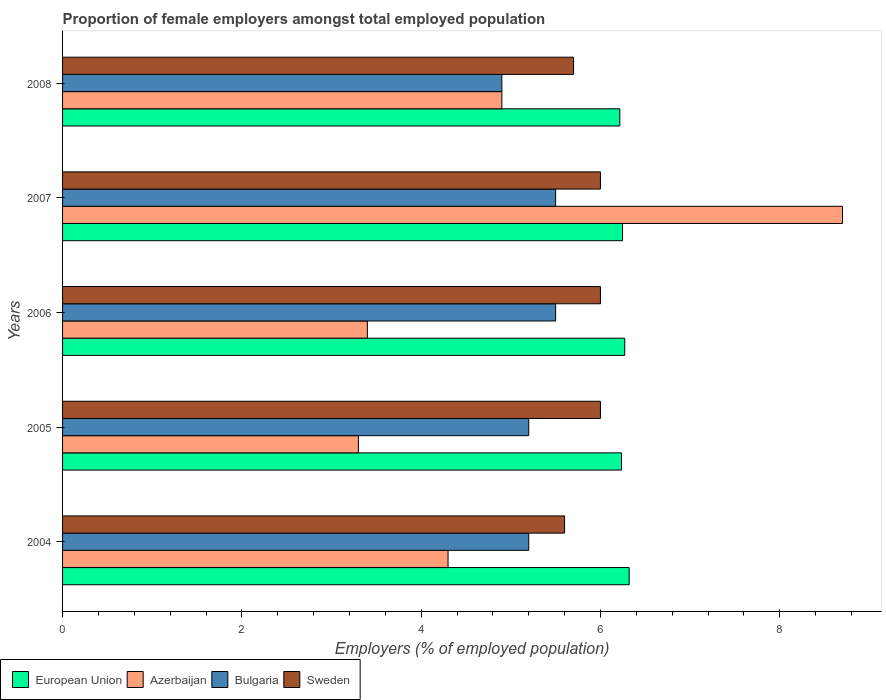How many different coloured bars are there?
Give a very brief answer. 4. Are the number of bars on each tick of the Y-axis equal?
Offer a very short reply. Yes. How many bars are there on the 5th tick from the bottom?
Keep it short and to the point. 4. What is the proportion of female employers in European Union in 2004?
Provide a succinct answer. 6.32. Across all years, what is the maximum proportion of female employers in Azerbaijan?
Offer a terse response. 8.7. Across all years, what is the minimum proportion of female employers in European Union?
Your response must be concise. 6.22. In which year was the proportion of female employers in Azerbaijan maximum?
Provide a short and direct response. 2007. In which year was the proportion of female employers in European Union minimum?
Give a very brief answer. 2008. What is the total proportion of female employers in European Union in the graph?
Your answer should be compact. 31.29. What is the difference between the proportion of female employers in Sweden in 2004 and the proportion of female employers in European Union in 2007?
Your answer should be compact. -0.65. What is the average proportion of female employers in European Union per year?
Make the answer very short. 6.26. In the year 2004, what is the difference between the proportion of female employers in Sweden and proportion of female employers in European Union?
Offer a terse response. -0.72. What is the ratio of the proportion of female employers in Bulgaria in 2005 to that in 2008?
Your response must be concise. 1.06. Is the proportion of female employers in Azerbaijan in 2005 less than that in 2008?
Keep it short and to the point. Yes. What is the difference between the highest and the second highest proportion of female employers in European Union?
Give a very brief answer. 0.05. What is the difference between the highest and the lowest proportion of female employers in Bulgaria?
Give a very brief answer. 0.6. In how many years, is the proportion of female employers in Bulgaria greater than the average proportion of female employers in Bulgaria taken over all years?
Offer a very short reply. 2. What does the 4th bar from the top in 2006 represents?
Ensure brevity in your answer.  European Union. What does the 3rd bar from the bottom in 2004 represents?
Your answer should be very brief. Bulgaria. How many bars are there?
Provide a short and direct response. 20. Are all the bars in the graph horizontal?
Your answer should be very brief. Yes. How many years are there in the graph?
Make the answer very short. 5. What is the difference between two consecutive major ticks on the X-axis?
Keep it short and to the point. 2. Does the graph contain grids?
Offer a very short reply. No. Where does the legend appear in the graph?
Make the answer very short. Bottom left. How many legend labels are there?
Provide a short and direct response. 4. How are the legend labels stacked?
Make the answer very short. Horizontal. What is the title of the graph?
Your response must be concise. Proportion of female employers amongst total employed population. Does "Lao PDR" appear as one of the legend labels in the graph?
Make the answer very short. No. What is the label or title of the X-axis?
Make the answer very short. Employers (% of employed population). What is the label or title of the Y-axis?
Ensure brevity in your answer.  Years. What is the Employers (% of employed population) of European Union in 2004?
Offer a very short reply. 6.32. What is the Employers (% of employed population) in Azerbaijan in 2004?
Make the answer very short. 4.3. What is the Employers (% of employed population) of Bulgaria in 2004?
Ensure brevity in your answer.  5.2. What is the Employers (% of employed population) in Sweden in 2004?
Provide a succinct answer. 5.6. What is the Employers (% of employed population) of European Union in 2005?
Your answer should be compact. 6.23. What is the Employers (% of employed population) in Azerbaijan in 2005?
Offer a terse response. 3.3. What is the Employers (% of employed population) of Bulgaria in 2005?
Keep it short and to the point. 5.2. What is the Employers (% of employed population) in Sweden in 2005?
Your answer should be very brief. 6. What is the Employers (% of employed population) in European Union in 2006?
Your response must be concise. 6.27. What is the Employers (% of employed population) of Azerbaijan in 2006?
Ensure brevity in your answer.  3.4. What is the Employers (% of employed population) of Bulgaria in 2006?
Provide a succinct answer. 5.5. What is the Employers (% of employed population) in Sweden in 2006?
Offer a very short reply. 6. What is the Employers (% of employed population) of European Union in 2007?
Keep it short and to the point. 6.25. What is the Employers (% of employed population) of Azerbaijan in 2007?
Provide a short and direct response. 8.7. What is the Employers (% of employed population) in Bulgaria in 2007?
Offer a terse response. 5.5. What is the Employers (% of employed population) in Sweden in 2007?
Make the answer very short. 6. What is the Employers (% of employed population) in European Union in 2008?
Provide a short and direct response. 6.22. What is the Employers (% of employed population) of Azerbaijan in 2008?
Keep it short and to the point. 4.9. What is the Employers (% of employed population) in Bulgaria in 2008?
Your answer should be compact. 4.9. What is the Employers (% of employed population) in Sweden in 2008?
Your answer should be very brief. 5.7. Across all years, what is the maximum Employers (% of employed population) in European Union?
Your response must be concise. 6.32. Across all years, what is the maximum Employers (% of employed population) of Azerbaijan?
Keep it short and to the point. 8.7. Across all years, what is the maximum Employers (% of employed population) in Bulgaria?
Your answer should be very brief. 5.5. Across all years, what is the minimum Employers (% of employed population) in European Union?
Your response must be concise. 6.22. Across all years, what is the minimum Employers (% of employed population) of Azerbaijan?
Offer a very short reply. 3.3. Across all years, what is the minimum Employers (% of employed population) of Bulgaria?
Give a very brief answer. 4.9. Across all years, what is the minimum Employers (% of employed population) of Sweden?
Provide a short and direct response. 5.6. What is the total Employers (% of employed population) of European Union in the graph?
Provide a succinct answer. 31.29. What is the total Employers (% of employed population) of Azerbaijan in the graph?
Your answer should be compact. 24.6. What is the total Employers (% of employed population) of Bulgaria in the graph?
Your response must be concise. 26.3. What is the total Employers (% of employed population) of Sweden in the graph?
Your response must be concise. 29.3. What is the difference between the Employers (% of employed population) of European Union in 2004 and that in 2005?
Keep it short and to the point. 0.09. What is the difference between the Employers (% of employed population) in Azerbaijan in 2004 and that in 2005?
Your answer should be very brief. 1. What is the difference between the Employers (% of employed population) of European Union in 2004 and that in 2006?
Provide a short and direct response. 0.05. What is the difference between the Employers (% of employed population) of Sweden in 2004 and that in 2006?
Offer a terse response. -0.4. What is the difference between the Employers (% of employed population) in European Union in 2004 and that in 2007?
Ensure brevity in your answer.  0.07. What is the difference between the Employers (% of employed population) of Azerbaijan in 2004 and that in 2007?
Offer a terse response. -4.4. What is the difference between the Employers (% of employed population) of Sweden in 2004 and that in 2007?
Your answer should be very brief. -0.4. What is the difference between the Employers (% of employed population) of European Union in 2004 and that in 2008?
Your answer should be very brief. 0.1. What is the difference between the Employers (% of employed population) in Azerbaijan in 2004 and that in 2008?
Provide a short and direct response. -0.6. What is the difference between the Employers (% of employed population) of European Union in 2005 and that in 2006?
Provide a succinct answer. -0.04. What is the difference between the Employers (% of employed population) in Bulgaria in 2005 and that in 2006?
Offer a very short reply. -0.3. What is the difference between the Employers (% of employed population) in Sweden in 2005 and that in 2006?
Provide a succinct answer. 0. What is the difference between the Employers (% of employed population) of European Union in 2005 and that in 2007?
Your answer should be compact. -0.01. What is the difference between the Employers (% of employed population) in Azerbaijan in 2005 and that in 2007?
Make the answer very short. -5.4. What is the difference between the Employers (% of employed population) in Bulgaria in 2005 and that in 2007?
Keep it short and to the point. -0.3. What is the difference between the Employers (% of employed population) in Sweden in 2005 and that in 2007?
Your response must be concise. 0. What is the difference between the Employers (% of employed population) of European Union in 2005 and that in 2008?
Provide a short and direct response. 0.02. What is the difference between the Employers (% of employed population) in Bulgaria in 2005 and that in 2008?
Ensure brevity in your answer.  0.3. What is the difference between the Employers (% of employed population) in Sweden in 2005 and that in 2008?
Provide a short and direct response. 0.3. What is the difference between the Employers (% of employed population) of European Union in 2006 and that in 2007?
Make the answer very short. 0.02. What is the difference between the Employers (% of employed population) in Bulgaria in 2006 and that in 2007?
Keep it short and to the point. 0. What is the difference between the Employers (% of employed population) of European Union in 2006 and that in 2008?
Your response must be concise. 0.06. What is the difference between the Employers (% of employed population) in Azerbaijan in 2006 and that in 2008?
Keep it short and to the point. -1.5. What is the difference between the Employers (% of employed population) in Bulgaria in 2006 and that in 2008?
Provide a short and direct response. 0.6. What is the difference between the Employers (% of employed population) in Sweden in 2006 and that in 2008?
Offer a terse response. 0.3. What is the difference between the Employers (% of employed population) of European Union in 2007 and that in 2008?
Keep it short and to the point. 0.03. What is the difference between the Employers (% of employed population) of Azerbaijan in 2007 and that in 2008?
Your answer should be compact. 3.8. What is the difference between the Employers (% of employed population) in Sweden in 2007 and that in 2008?
Provide a succinct answer. 0.3. What is the difference between the Employers (% of employed population) in European Union in 2004 and the Employers (% of employed population) in Azerbaijan in 2005?
Your response must be concise. 3.02. What is the difference between the Employers (% of employed population) in European Union in 2004 and the Employers (% of employed population) in Bulgaria in 2005?
Offer a very short reply. 1.12. What is the difference between the Employers (% of employed population) of European Union in 2004 and the Employers (% of employed population) of Sweden in 2005?
Ensure brevity in your answer.  0.32. What is the difference between the Employers (% of employed population) in Azerbaijan in 2004 and the Employers (% of employed population) in Bulgaria in 2005?
Make the answer very short. -0.9. What is the difference between the Employers (% of employed population) of European Union in 2004 and the Employers (% of employed population) of Azerbaijan in 2006?
Offer a terse response. 2.92. What is the difference between the Employers (% of employed population) in European Union in 2004 and the Employers (% of employed population) in Bulgaria in 2006?
Provide a short and direct response. 0.82. What is the difference between the Employers (% of employed population) in European Union in 2004 and the Employers (% of employed population) in Sweden in 2006?
Your response must be concise. 0.32. What is the difference between the Employers (% of employed population) of Bulgaria in 2004 and the Employers (% of employed population) of Sweden in 2006?
Give a very brief answer. -0.8. What is the difference between the Employers (% of employed population) of European Union in 2004 and the Employers (% of employed population) of Azerbaijan in 2007?
Give a very brief answer. -2.38. What is the difference between the Employers (% of employed population) of European Union in 2004 and the Employers (% of employed population) of Bulgaria in 2007?
Your answer should be very brief. 0.82. What is the difference between the Employers (% of employed population) in European Union in 2004 and the Employers (% of employed population) in Sweden in 2007?
Offer a terse response. 0.32. What is the difference between the Employers (% of employed population) in Azerbaijan in 2004 and the Employers (% of employed population) in Sweden in 2007?
Provide a succinct answer. -1.7. What is the difference between the Employers (% of employed population) in Bulgaria in 2004 and the Employers (% of employed population) in Sweden in 2007?
Keep it short and to the point. -0.8. What is the difference between the Employers (% of employed population) of European Union in 2004 and the Employers (% of employed population) of Azerbaijan in 2008?
Offer a terse response. 1.42. What is the difference between the Employers (% of employed population) in European Union in 2004 and the Employers (% of employed population) in Bulgaria in 2008?
Provide a succinct answer. 1.42. What is the difference between the Employers (% of employed population) in European Union in 2004 and the Employers (% of employed population) in Sweden in 2008?
Your response must be concise. 0.62. What is the difference between the Employers (% of employed population) of Azerbaijan in 2004 and the Employers (% of employed population) of Bulgaria in 2008?
Offer a terse response. -0.6. What is the difference between the Employers (% of employed population) in European Union in 2005 and the Employers (% of employed population) in Azerbaijan in 2006?
Make the answer very short. 2.83. What is the difference between the Employers (% of employed population) of European Union in 2005 and the Employers (% of employed population) of Bulgaria in 2006?
Make the answer very short. 0.73. What is the difference between the Employers (% of employed population) of European Union in 2005 and the Employers (% of employed population) of Sweden in 2006?
Your answer should be compact. 0.23. What is the difference between the Employers (% of employed population) of Azerbaijan in 2005 and the Employers (% of employed population) of Bulgaria in 2006?
Provide a succinct answer. -2.2. What is the difference between the Employers (% of employed population) in European Union in 2005 and the Employers (% of employed population) in Azerbaijan in 2007?
Provide a short and direct response. -2.47. What is the difference between the Employers (% of employed population) in European Union in 2005 and the Employers (% of employed population) in Bulgaria in 2007?
Give a very brief answer. 0.73. What is the difference between the Employers (% of employed population) in European Union in 2005 and the Employers (% of employed population) in Sweden in 2007?
Offer a very short reply. 0.23. What is the difference between the Employers (% of employed population) in Bulgaria in 2005 and the Employers (% of employed population) in Sweden in 2007?
Provide a short and direct response. -0.8. What is the difference between the Employers (% of employed population) in European Union in 2005 and the Employers (% of employed population) in Azerbaijan in 2008?
Offer a terse response. 1.33. What is the difference between the Employers (% of employed population) in European Union in 2005 and the Employers (% of employed population) in Bulgaria in 2008?
Provide a succinct answer. 1.33. What is the difference between the Employers (% of employed population) in European Union in 2005 and the Employers (% of employed population) in Sweden in 2008?
Your response must be concise. 0.53. What is the difference between the Employers (% of employed population) of Azerbaijan in 2005 and the Employers (% of employed population) of Bulgaria in 2008?
Ensure brevity in your answer.  -1.6. What is the difference between the Employers (% of employed population) in Azerbaijan in 2005 and the Employers (% of employed population) in Sweden in 2008?
Offer a terse response. -2.4. What is the difference between the Employers (% of employed population) in European Union in 2006 and the Employers (% of employed population) in Azerbaijan in 2007?
Provide a succinct answer. -2.43. What is the difference between the Employers (% of employed population) in European Union in 2006 and the Employers (% of employed population) in Bulgaria in 2007?
Offer a terse response. 0.77. What is the difference between the Employers (% of employed population) in European Union in 2006 and the Employers (% of employed population) in Sweden in 2007?
Provide a succinct answer. 0.27. What is the difference between the Employers (% of employed population) of Azerbaijan in 2006 and the Employers (% of employed population) of Bulgaria in 2007?
Make the answer very short. -2.1. What is the difference between the Employers (% of employed population) in Bulgaria in 2006 and the Employers (% of employed population) in Sweden in 2007?
Your response must be concise. -0.5. What is the difference between the Employers (% of employed population) of European Union in 2006 and the Employers (% of employed population) of Azerbaijan in 2008?
Provide a succinct answer. 1.37. What is the difference between the Employers (% of employed population) in European Union in 2006 and the Employers (% of employed population) in Bulgaria in 2008?
Ensure brevity in your answer.  1.37. What is the difference between the Employers (% of employed population) in European Union in 2006 and the Employers (% of employed population) in Sweden in 2008?
Keep it short and to the point. 0.57. What is the difference between the Employers (% of employed population) of Azerbaijan in 2006 and the Employers (% of employed population) of Sweden in 2008?
Your answer should be very brief. -2.3. What is the difference between the Employers (% of employed population) of European Union in 2007 and the Employers (% of employed population) of Azerbaijan in 2008?
Your response must be concise. 1.35. What is the difference between the Employers (% of employed population) of European Union in 2007 and the Employers (% of employed population) of Bulgaria in 2008?
Keep it short and to the point. 1.35. What is the difference between the Employers (% of employed population) in European Union in 2007 and the Employers (% of employed population) in Sweden in 2008?
Keep it short and to the point. 0.55. What is the average Employers (% of employed population) in European Union per year?
Your answer should be compact. 6.26. What is the average Employers (% of employed population) of Azerbaijan per year?
Make the answer very short. 4.92. What is the average Employers (% of employed population) in Bulgaria per year?
Your answer should be very brief. 5.26. What is the average Employers (% of employed population) in Sweden per year?
Your response must be concise. 5.86. In the year 2004, what is the difference between the Employers (% of employed population) of European Union and Employers (% of employed population) of Azerbaijan?
Make the answer very short. 2.02. In the year 2004, what is the difference between the Employers (% of employed population) of European Union and Employers (% of employed population) of Bulgaria?
Provide a short and direct response. 1.12. In the year 2004, what is the difference between the Employers (% of employed population) in European Union and Employers (% of employed population) in Sweden?
Provide a short and direct response. 0.72. In the year 2004, what is the difference between the Employers (% of employed population) of Azerbaijan and Employers (% of employed population) of Bulgaria?
Keep it short and to the point. -0.9. In the year 2004, what is the difference between the Employers (% of employed population) of Azerbaijan and Employers (% of employed population) of Sweden?
Make the answer very short. -1.3. In the year 2004, what is the difference between the Employers (% of employed population) of Bulgaria and Employers (% of employed population) of Sweden?
Your answer should be very brief. -0.4. In the year 2005, what is the difference between the Employers (% of employed population) of European Union and Employers (% of employed population) of Azerbaijan?
Provide a succinct answer. 2.93. In the year 2005, what is the difference between the Employers (% of employed population) in European Union and Employers (% of employed population) in Bulgaria?
Give a very brief answer. 1.03. In the year 2005, what is the difference between the Employers (% of employed population) of European Union and Employers (% of employed population) of Sweden?
Your response must be concise. 0.23. In the year 2005, what is the difference between the Employers (% of employed population) in Azerbaijan and Employers (% of employed population) in Bulgaria?
Provide a short and direct response. -1.9. In the year 2005, what is the difference between the Employers (% of employed population) in Azerbaijan and Employers (% of employed population) in Sweden?
Offer a terse response. -2.7. In the year 2006, what is the difference between the Employers (% of employed population) of European Union and Employers (% of employed population) of Azerbaijan?
Your response must be concise. 2.87. In the year 2006, what is the difference between the Employers (% of employed population) in European Union and Employers (% of employed population) in Bulgaria?
Ensure brevity in your answer.  0.77. In the year 2006, what is the difference between the Employers (% of employed population) of European Union and Employers (% of employed population) of Sweden?
Your answer should be very brief. 0.27. In the year 2006, what is the difference between the Employers (% of employed population) of Bulgaria and Employers (% of employed population) of Sweden?
Provide a short and direct response. -0.5. In the year 2007, what is the difference between the Employers (% of employed population) in European Union and Employers (% of employed population) in Azerbaijan?
Offer a terse response. -2.45. In the year 2007, what is the difference between the Employers (% of employed population) in European Union and Employers (% of employed population) in Bulgaria?
Keep it short and to the point. 0.75. In the year 2007, what is the difference between the Employers (% of employed population) in European Union and Employers (% of employed population) in Sweden?
Make the answer very short. 0.25. In the year 2007, what is the difference between the Employers (% of employed population) in Bulgaria and Employers (% of employed population) in Sweden?
Keep it short and to the point. -0.5. In the year 2008, what is the difference between the Employers (% of employed population) in European Union and Employers (% of employed population) in Azerbaijan?
Keep it short and to the point. 1.32. In the year 2008, what is the difference between the Employers (% of employed population) of European Union and Employers (% of employed population) of Bulgaria?
Your answer should be compact. 1.32. In the year 2008, what is the difference between the Employers (% of employed population) in European Union and Employers (% of employed population) in Sweden?
Offer a very short reply. 0.52. In the year 2008, what is the difference between the Employers (% of employed population) of Azerbaijan and Employers (% of employed population) of Bulgaria?
Your response must be concise. 0. In the year 2008, what is the difference between the Employers (% of employed population) of Azerbaijan and Employers (% of employed population) of Sweden?
Your answer should be very brief. -0.8. What is the ratio of the Employers (% of employed population) in European Union in 2004 to that in 2005?
Your answer should be very brief. 1.01. What is the ratio of the Employers (% of employed population) in Azerbaijan in 2004 to that in 2005?
Provide a succinct answer. 1.3. What is the ratio of the Employers (% of employed population) of Sweden in 2004 to that in 2005?
Ensure brevity in your answer.  0.93. What is the ratio of the Employers (% of employed population) in European Union in 2004 to that in 2006?
Your answer should be compact. 1.01. What is the ratio of the Employers (% of employed population) of Azerbaijan in 2004 to that in 2006?
Ensure brevity in your answer.  1.26. What is the ratio of the Employers (% of employed population) of Bulgaria in 2004 to that in 2006?
Provide a succinct answer. 0.95. What is the ratio of the Employers (% of employed population) in European Union in 2004 to that in 2007?
Your response must be concise. 1.01. What is the ratio of the Employers (% of employed population) of Azerbaijan in 2004 to that in 2007?
Offer a very short reply. 0.49. What is the ratio of the Employers (% of employed population) in Bulgaria in 2004 to that in 2007?
Keep it short and to the point. 0.95. What is the ratio of the Employers (% of employed population) in Sweden in 2004 to that in 2007?
Make the answer very short. 0.93. What is the ratio of the Employers (% of employed population) of European Union in 2004 to that in 2008?
Your answer should be compact. 1.02. What is the ratio of the Employers (% of employed population) in Azerbaijan in 2004 to that in 2008?
Give a very brief answer. 0.88. What is the ratio of the Employers (% of employed population) in Bulgaria in 2004 to that in 2008?
Ensure brevity in your answer.  1.06. What is the ratio of the Employers (% of employed population) of Sweden in 2004 to that in 2008?
Offer a very short reply. 0.98. What is the ratio of the Employers (% of employed population) of European Union in 2005 to that in 2006?
Offer a terse response. 0.99. What is the ratio of the Employers (% of employed population) of Azerbaijan in 2005 to that in 2006?
Make the answer very short. 0.97. What is the ratio of the Employers (% of employed population) in Bulgaria in 2005 to that in 2006?
Give a very brief answer. 0.95. What is the ratio of the Employers (% of employed population) of Azerbaijan in 2005 to that in 2007?
Your response must be concise. 0.38. What is the ratio of the Employers (% of employed population) of Bulgaria in 2005 to that in 2007?
Provide a short and direct response. 0.95. What is the ratio of the Employers (% of employed population) in Sweden in 2005 to that in 2007?
Your response must be concise. 1. What is the ratio of the Employers (% of employed population) of European Union in 2005 to that in 2008?
Keep it short and to the point. 1. What is the ratio of the Employers (% of employed population) in Azerbaijan in 2005 to that in 2008?
Offer a very short reply. 0.67. What is the ratio of the Employers (% of employed population) of Bulgaria in 2005 to that in 2008?
Provide a succinct answer. 1.06. What is the ratio of the Employers (% of employed population) in Sweden in 2005 to that in 2008?
Keep it short and to the point. 1.05. What is the ratio of the Employers (% of employed population) in Azerbaijan in 2006 to that in 2007?
Provide a succinct answer. 0.39. What is the ratio of the Employers (% of employed population) of European Union in 2006 to that in 2008?
Your response must be concise. 1.01. What is the ratio of the Employers (% of employed population) of Azerbaijan in 2006 to that in 2008?
Your answer should be compact. 0.69. What is the ratio of the Employers (% of employed population) in Bulgaria in 2006 to that in 2008?
Make the answer very short. 1.12. What is the ratio of the Employers (% of employed population) in Sweden in 2006 to that in 2008?
Your response must be concise. 1.05. What is the ratio of the Employers (% of employed population) in Azerbaijan in 2007 to that in 2008?
Your response must be concise. 1.78. What is the ratio of the Employers (% of employed population) of Bulgaria in 2007 to that in 2008?
Your answer should be very brief. 1.12. What is the ratio of the Employers (% of employed population) in Sweden in 2007 to that in 2008?
Your answer should be very brief. 1.05. What is the difference between the highest and the second highest Employers (% of employed population) in European Union?
Provide a short and direct response. 0.05. What is the difference between the highest and the lowest Employers (% of employed population) in European Union?
Offer a very short reply. 0.1. What is the difference between the highest and the lowest Employers (% of employed population) in Azerbaijan?
Offer a terse response. 5.4. What is the difference between the highest and the lowest Employers (% of employed population) of Bulgaria?
Ensure brevity in your answer.  0.6. 